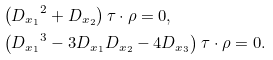<formula> <loc_0><loc_0><loc_500><loc_500>& \left ( { D _ { x _ { 1 } } } ^ { 2 } + D _ { x _ { 2 } } \right ) \tau \cdot \rho = 0 , \\ & \left ( { D _ { x _ { 1 } } } ^ { 3 } - 3 D _ { x _ { 1 } } D _ { x _ { 2 } } - 4 D _ { x _ { 3 } } \right ) \tau \cdot \rho = 0 .</formula> 